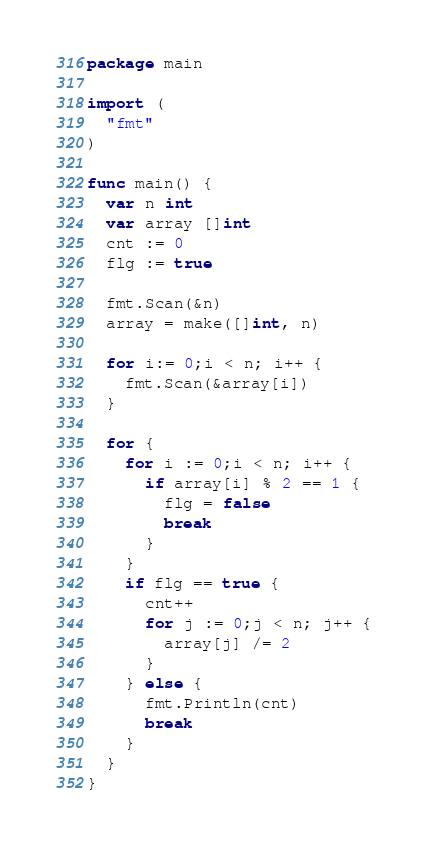Convert code to text. <code><loc_0><loc_0><loc_500><loc_500><_Go_>package main

import (
  "fmt"
)

func main() {
  var n int
  var array []int
  cnt := 0
  flg := true
  
  fmt.Scan(&n)
  array = make([]int, n)

  for i:= 0;i < n; i++ {
    fmt.Scan(&array[i])
  }
  
  for {
    for i := 0;i < n; i++ {
      if array[i] % 2 == 1 {
        flg = false
      	break
      }
    }
    if flg == true {
      cnt++
      for j := 0;j < n; j++ {
        array[j] /= 2
      }
    } else {
      fmt.Println(cnt)
      break
    }
  }
}
</code> 